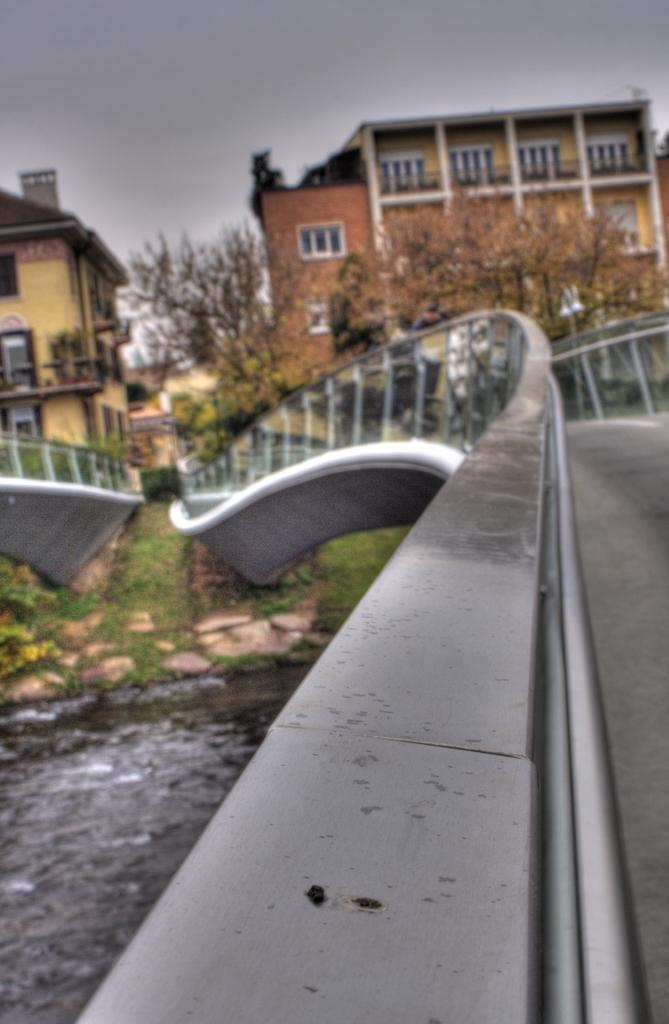What structures can be seen in the image? There are bridges, buildings, and trees in the image. What natural elements are present in the image? There is water, grass, plants, and trees in the image. What part of the natural environment is visible in the image? The sky is visible in the image. What type of fruit is being used for writing in the image? There is no fruit present in the image, nor is there any writing. 